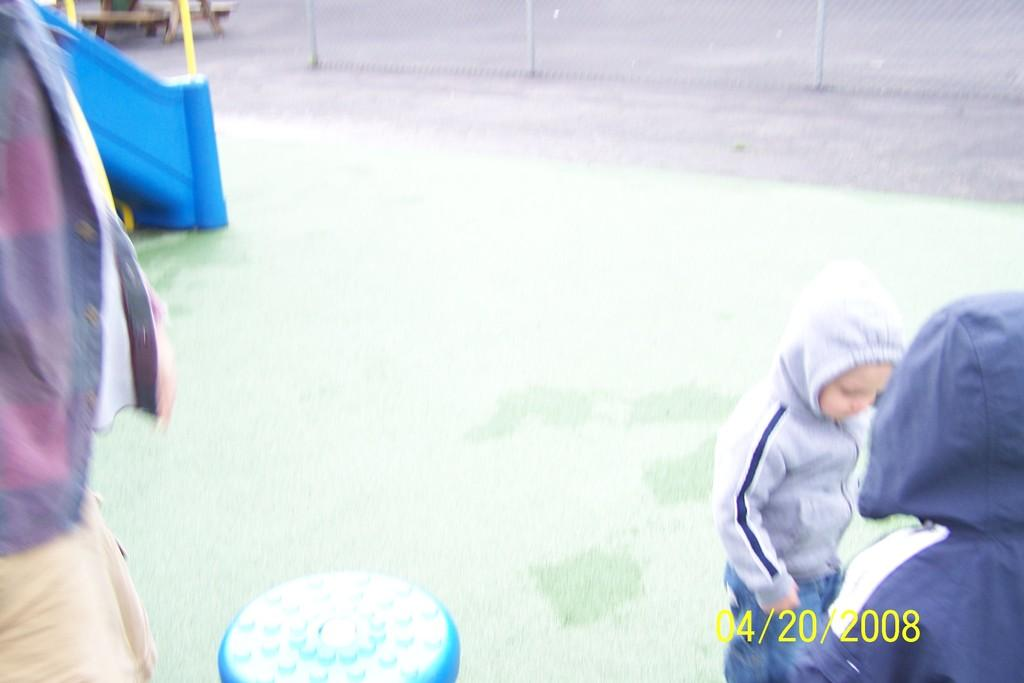Who or what can be seen in the image? There are people in the image. What is located at the bottom of the image? There is an object at the bottom of the image. Can you describe the appearance of the object? The object has a mesh-like appearance. What type of furniture is present in the image? There is a bench in the image. What type of food is being prepared on the bench in the image? There is no food preparation or bench visible in the image; the bench is a separate object. 